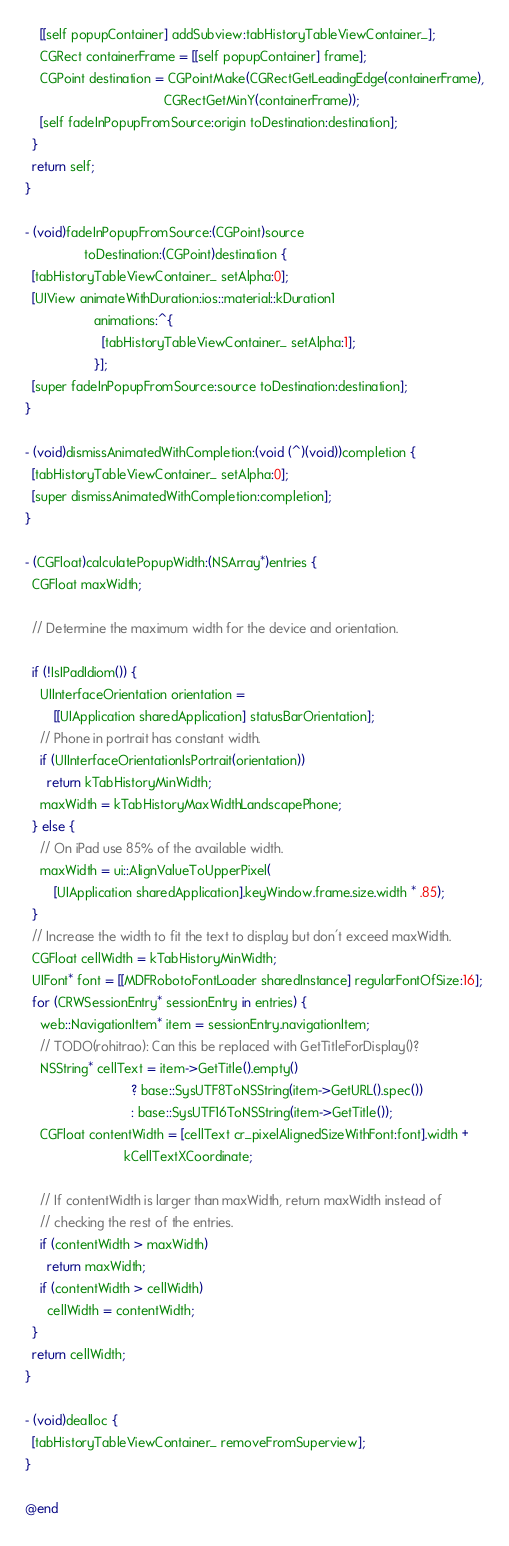<code> <loc_0><loc_0><loc_500><loc_500><_ObjectiveC_>
    [[self popupContainer] addSubview:tabHistoryTableViewContainer_];
    CGRect containerFrame = [[self popupContainer] frame];
    CGPoint destination = CGPointMake(CGRectGetLeadingEdge(containerFrame),
                                      CGRectGetMinY(containerFrame));
    [self fadeInPopupFromSource:origin toDestination:destination];
  }
  return self;
}

- (void)fadeInPopupFromSource:(CGPoint)source
                toDestination:(CGPoint)destination {
  [tabHistoryTableViewContainer_ setAlpha:0];
  [UIView animateWithDuration:ios::material::kDuration1
                   animations:^{
                     [tabHistoryTableViewContainer_ setAlpha:1];
                   }];
  [super fadeInPopupFromSource:source toDestination:destination];
}

- (void)dismissAnimatedWithCompletion:(void (^)(void))completion {
  [tabHistoryTableViewContainer_ setAlpha:0];
  [super dismissAnimatedWithCompletion:completion];
}

- (CGFloat)calculatePopupWidth:(NSArray*)entries {
  CGFloat maxWidth;

  // Determine the maximum width for the device and orientation.

  if (!IsIPadIdiom()) {
    UIInterfaceOrientation orientation =
        [[UIApplication sharedApplication] statusBarOrientation];
    // Phone in portrait has constant width.
    if (UIInterfaceOrientationIsPortrait(orientation))
      return kTabHistoryMinWidth;
    maxWidth = kTabHistoryMaxWidthLandscapePhone;
  } else {
    // On iPad use 85% of the available width.
    maxWidth = ui::AlignValueToUpperPixel(
        [UIApplication sharedApplication].keyWindow.frame.size.width * .85);
  }
  // Increase the width to fit the text to display but don't exceed maxWidth.
  CGFloat cellWidth = kTabHistoryMinWidth;
  UIFont* font = [[MDFRobotoFontLoader sharedInstance] regularFontOfSize:16];
  for (CRWSessionEntry* sessionEntry in entries) {
    web::NavigationItem* item = sessionEntry.navigationItem;
    // TODO(rohitrao): Can this be replaced with GetTitleForDisplay()?
    NSString* cellText = item->GetTitle().empty()
                             ? base::SysUTF8ToNSString(item->GetURL().spec())
                             : base::SysUTF16ToNSString(item->GetTitle());
    CGFloat contentWidth = [cellText cr_pixelAlignedSizeWithFont:font].width +
                           kCellTextXCoordinate;

    // If contentWidth is larger than maxWidth, return maxWidth instead of
    // checking the rest of the entries.
    if (contentWidth > maxWidth)
      return maxWidth;
    if (contentWidth > cellWidth)
      cellWidth = contentWidth;
  }
  return cellWidth;
}

- (void)dealloc {
  [tabHistoryTableViewContainer_ removeFromSuperview];
}

@end
</code> 